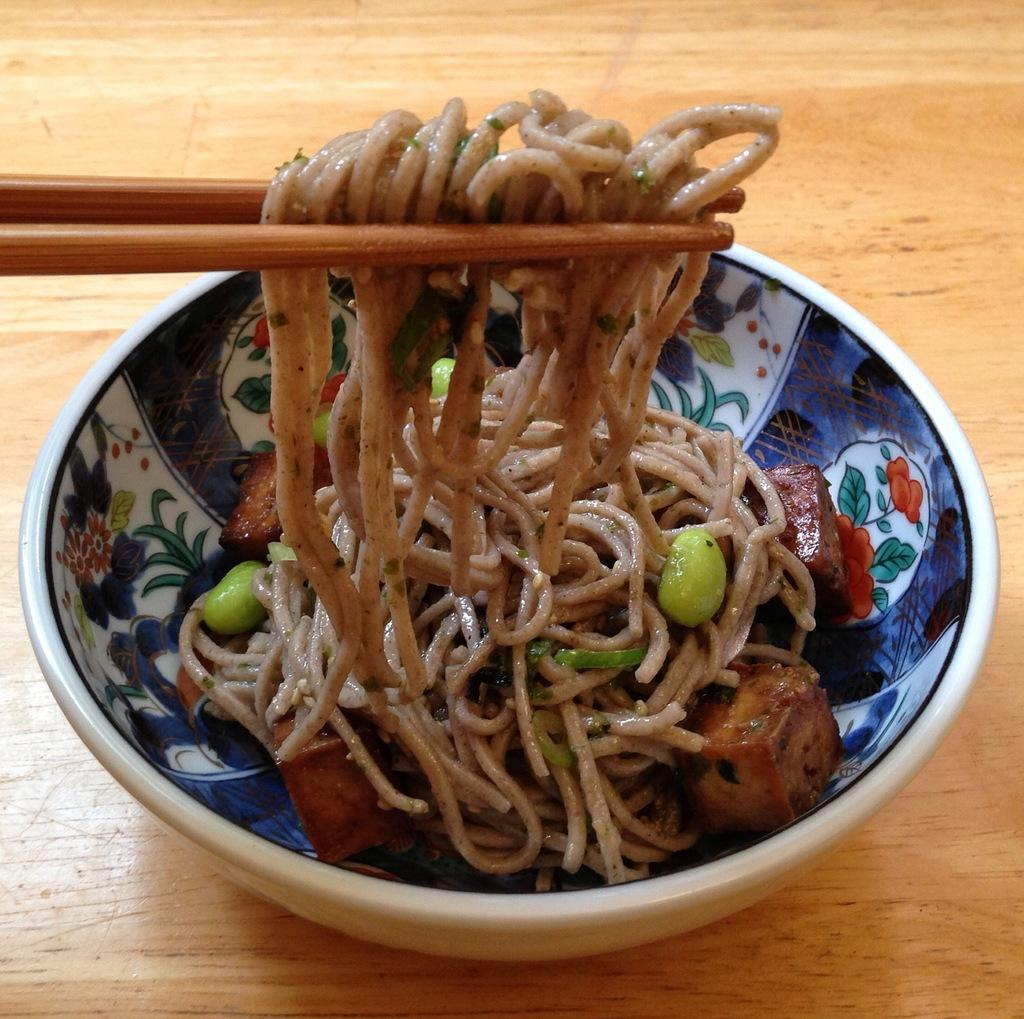What is in the bowl that is visible in the image? There is a bowl with noodles in the image. Where is the bowl located in the image? The bowl is placed on a table. What type of news can be seen on the dock in the image? There is no dock or news present in the image; it features a bowl of noodles placed on a table. 